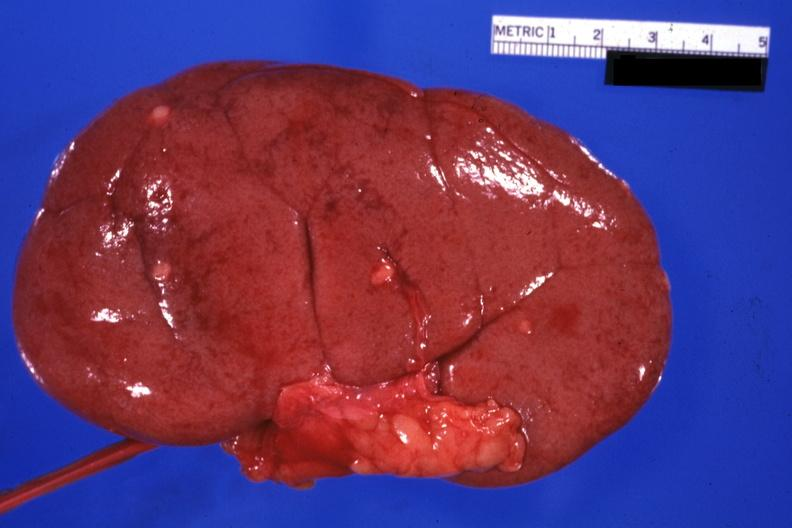s opened bladder with median lobe protruding into trigone area also present?
Answer the question using a single word or phrase. No 